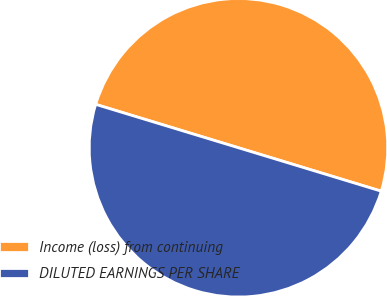Convert chart. <chart><loc_0><loc_0><loc_500><loc_500><pie_chart><fcel>Income (loss) from continuing<fcel>DILUTED EARNINGS PER SHARE<nl><fcel>50.0%<fcel>50.0%<nl></chart> 